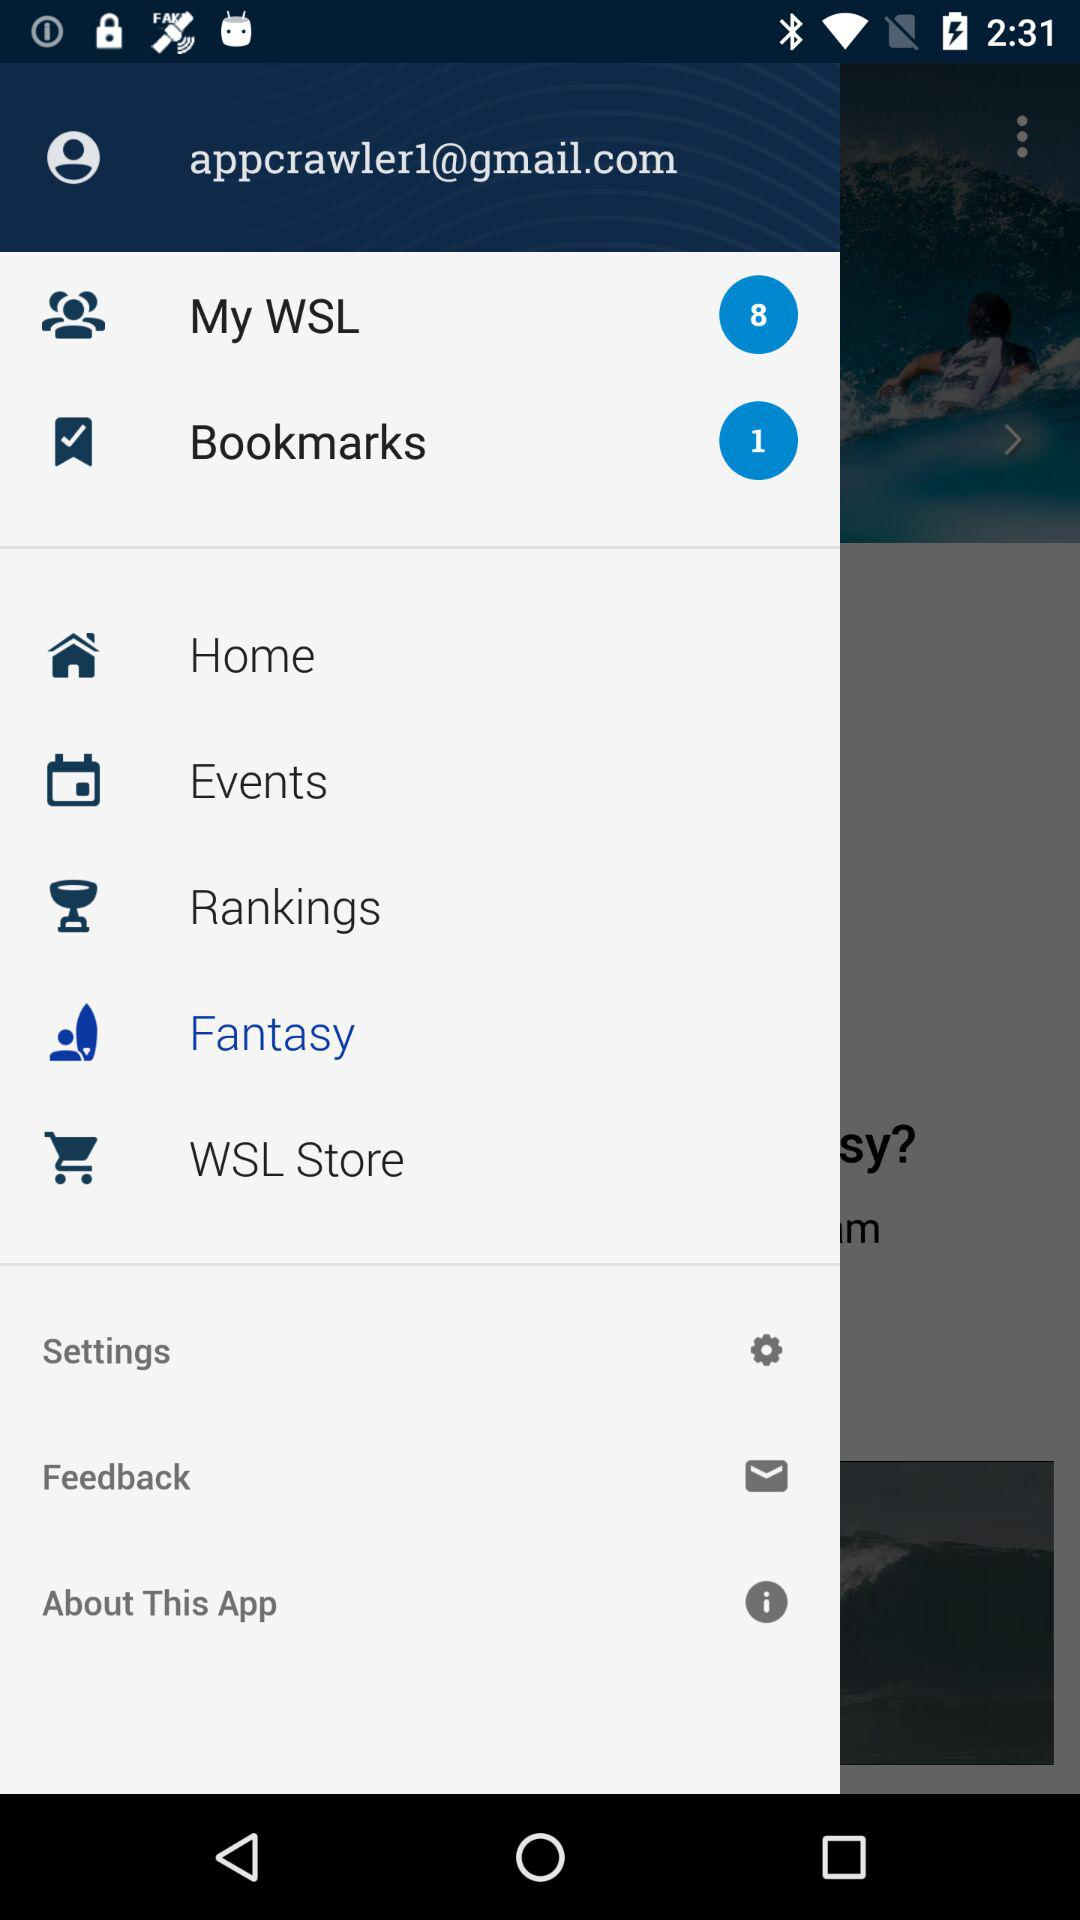What is the number of bookmarks? The number of bookmarks is 1. 